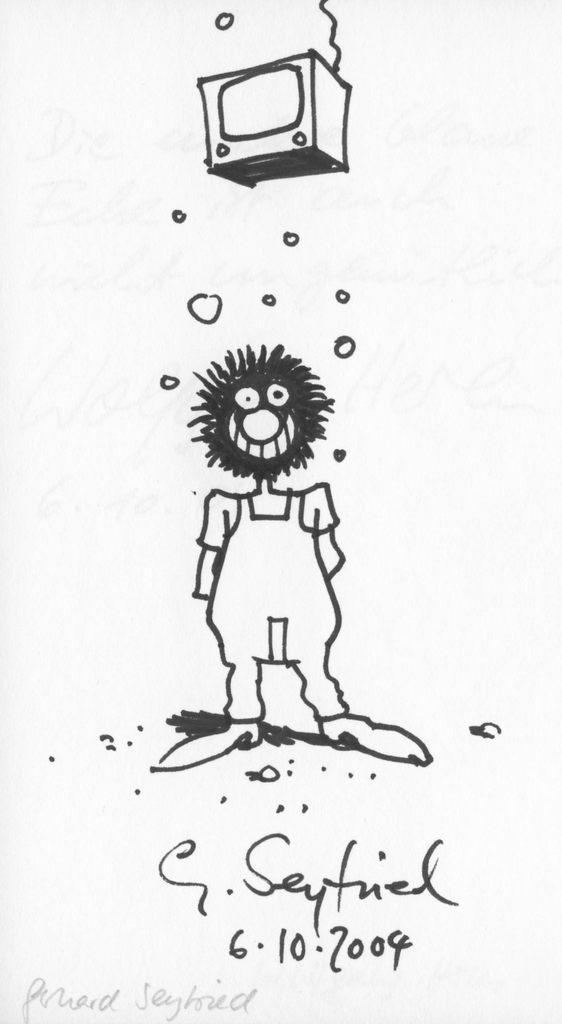How would you summarize this image in a sentence or two? In this picture there is a sketch of a person standing. At the top there is a television. At the bottom there is a text. At the back there is a white background. 